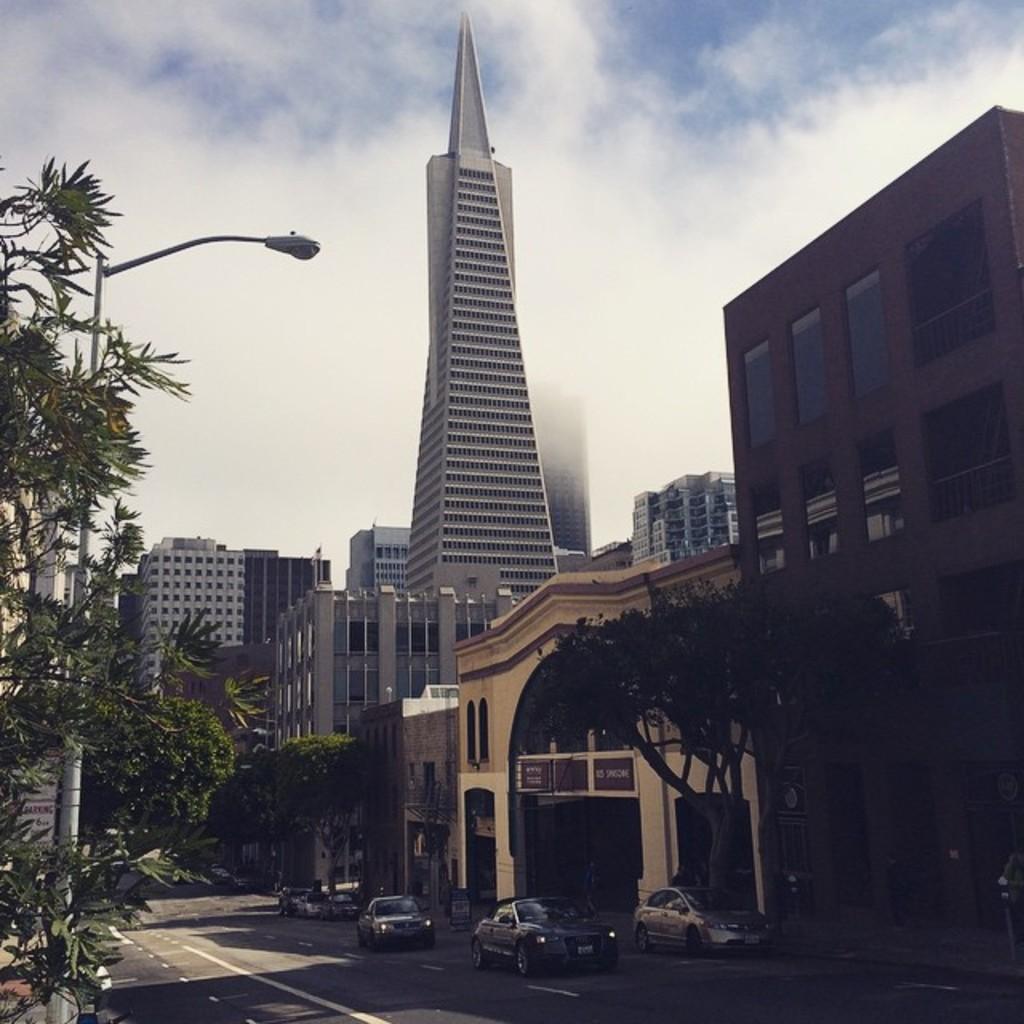Could you give a brief overview of what you see in this image? As we can see in the image there are buildings, street lamp, trees and cars. On the top there is sky. 